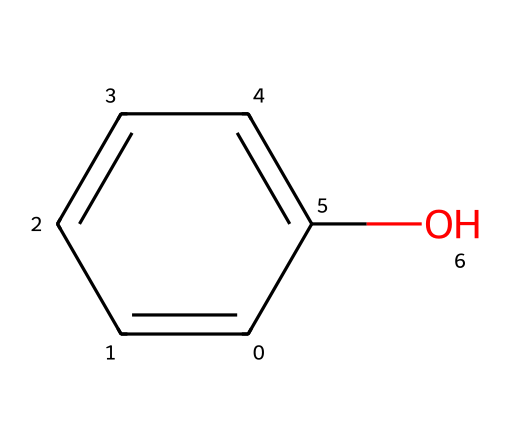What is the name of this chemical? Based on the SMILES representation c1ccccc1O, the structure includes a benzene ring (c1ccccc1) with a hydroxyl group (O) attached. This corresponds to the chemical name "phenol."
Answer: phenol How many carbon atoms are in this molecule? In the structure represented by the SMILES notation c1ccccc1O, there are six carbon atoms in the benzene ring part (c1ccccc1). Each 'c' represents a carbon atom.
Answer: six How many hydroxyl groups are present? The hydroxyl group (-OH) is indicated by the 'O' in the SMILES notation c1ccccc1O. Since there is only one 'O' connected to the benzene ring, it shows that there is one hydroxyl group present in the structure.
Answer: one What type of chemical bond connects the carbon and oxygen in the hydroxyl group? The connection between the carbon atom of the benzene ring and the oxygen in the hydroxyl group is a single covalent bond, which is indicative of the structure where a hydroxyl group attaches to an aromatic ring, without any double bond present.
Answer: single What property does the presence of the hydroxyl group impart to phenol? The presence of the hydroxyl group (-OH) in phenol contributes to its classification as an alcohol, providing it with properties such as solubility in water and making it a weak acid. The presence of the hydroxyl group enhances the molecule's reactivity compared to hydrocarbons.
Answer: acidity How many hydrogen atoms are bonded to the benzene ring in phenol? In phenol, there are five hydrogen atoms bonded to the benzene ring (as each carbon in benzene is typically bonded to one hydrogen), since one hydrogen is replaced by the hydroxyl group. This accounts for the general formula of phenol (C6H5OH), confirming that there are five hydrogen atoms remaining bonded to the ring.
Answer: five Is phenol classified as a primary or secondary alcohol? Phenol does not fit into the traditional classifications of primary or secondary alcohols since it is classified as an aromatic alcohol due to the structure of its benzene ring. The presence of the aromatic ring qualifies it uniquely compared to standard alcohols.
Answer: aromatic 